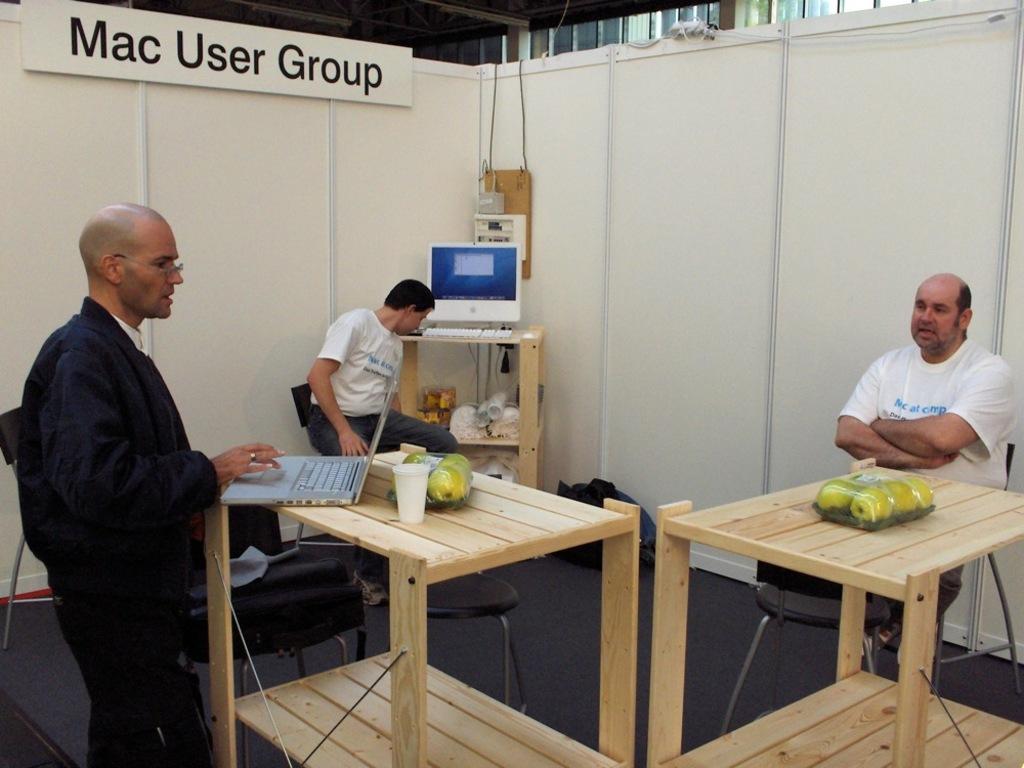What kind of computers do people use in this group?
Keep it short and to the point. Mac. What kind of user group is this?
Provide a succinct answer. Mac. 